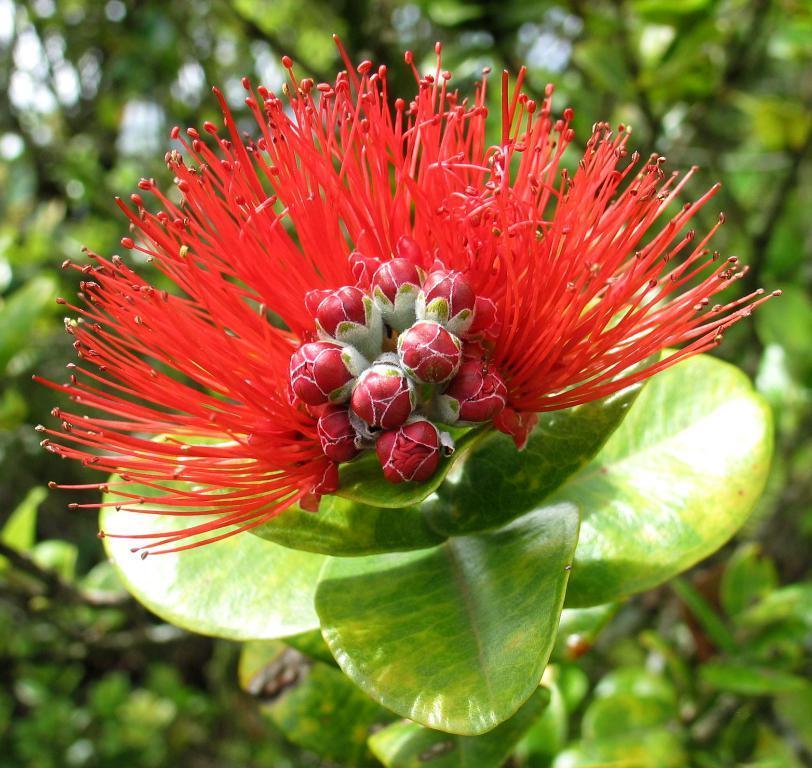Could you give a brief overview of what you see in this image? There is a plant with a red flower. 